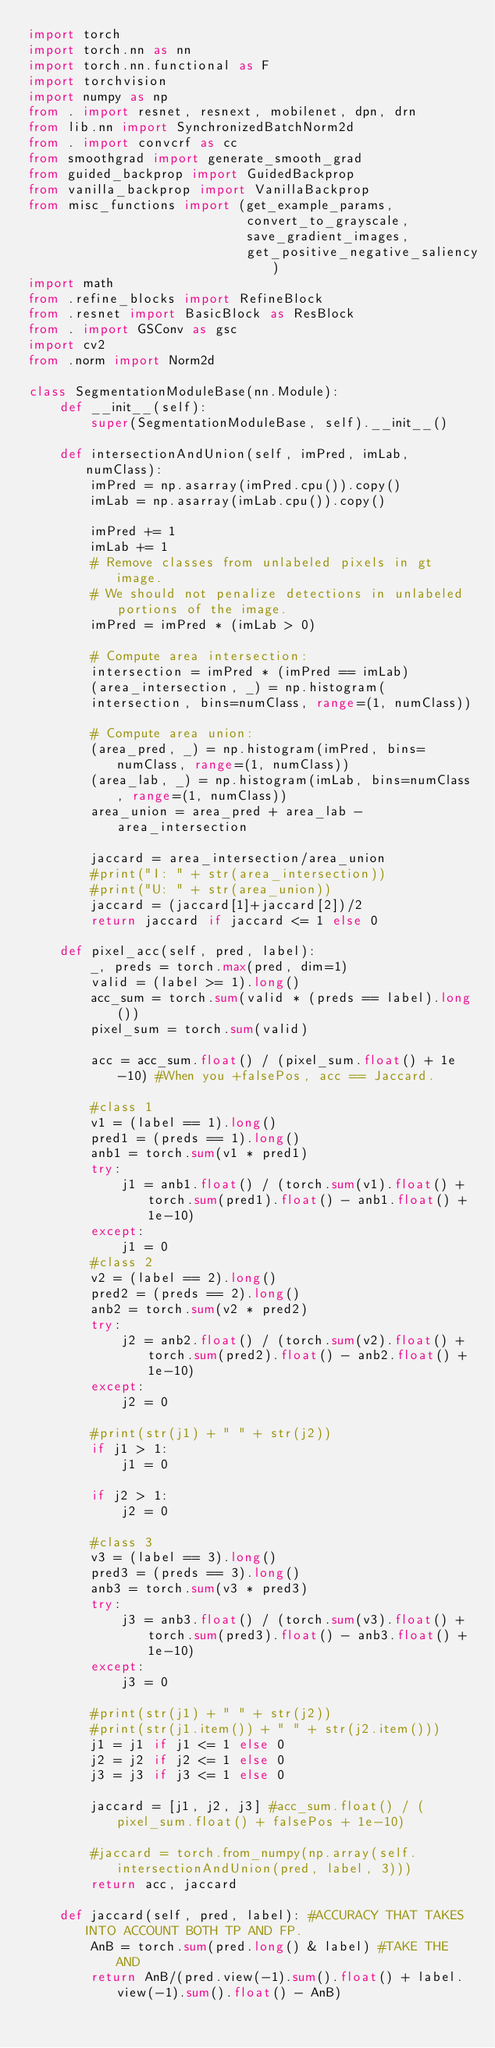<code> <loc_0><loc_0><loc_500><loc_500><_Python_>import torch
import torch.nn as nn
import torch.nn.functional as F
import torchvision
import numpy as np
from . import resnet, resnext, mobilenet, dpn, drn
from lib.nn import SynchronizedBatchNorm2d
from . import convcrf as cc
from smoothgrad import generate_smooth_grad
from guided_backprop import GuidedBackprop
from vanilla_backprop import VanillaBackprop
from misc_functions import (get_example_params,
                            convert_to_grayscale,
                            save_gradient_images,
                            get_positive_negative_saliency)
import math
from .refine_blocks import RefineBlock
from .resnet import BasicBlock as ResBlock
from . import GSConv as gsc
import cv2
from .norm import Norm2d

class SegmentationModuleBase(nn.Module):
    def __init__(self):
        super(SegmentationModuleBase, self).__init__()
    
    def intersectionAndUnion(self, imPred, imLab, numClass):
        imPred = np.asarray(imPred.cpu()).copy()
        imLab = np.asarray(imLab.cpu()).copy()

        imPred += 1
        imLab += 1
        # Remove classes from unlabeled pixels in gt image.
        # We should not penalize detections in unlabeled portions of the image.
        imPred = imPred * (imLab > 0)

        # Compute area intersection:
        intersection = imPred * (imPred == imLab)
        (area_intersection, _) = np.histogram(
        intersection, bins=numClass, range=(1, numClass))

        # Compute area union:
        (area_pred, _) = np.histogram(imPred, bins=numClass, range=(1, numClass))
        (area_lab, _) = np.histogram(imLab, bins=numClass, range=(1, numClass))
        area_union = area_pred + area_lab - area_intersection
        
        jaccard = area_intersection/area_union
        #print("I: " + str(area_intersection))
        #print("U: " + str(area_union))
        jaccard = (jaccard[1]+jaccard[2])/2
        return jaccard if jaccard <= 1 else 0

    def pixel_acc(self, pred, label):
        _, preds = torch.max(pred, dim=1)
        valid = (label >= 1).long()
        acc_sum = torch.sum(valid * (preds == label).long())
        pixel_sum = torch.sum(valid)

        acc = acc_sum.float() / (pixel_sum.float() + 1e-10) #When you +falsePos, acc == Jaccard.
        
        #class 1
        v1 = (label == 1).long()
        pred1 = (preds == 1).long()
        anb1 = torch.sum(v1 * pred1)
        try:
            j1 = anb1.float() / (torch.sum(v1).float() + torch.sum(pred1).float() - anb1.float() + 1e-10)
        except:
            j1 = 0
        #class 2 
        v2 = (label == 2).long()
        pred2 = (preds == 2).long()
        anb2 = torch.sum(v2 * pred2)
        try: 
            j2 = anb2.float() / (torch.sum(v2).float() + torch.sum(pred2).float() - anb2.float() + 1e-10)
        except:
            j2 = 0

        #print(str(j1) + " " + str(j2))
        if j1 > 1:
            j1 = 0

        if j2 > 1:
            j2 = 0
        
        #class 3
        v3 = (label == 3).long()
        pred3 = (preds == 3).long()
        anb3 = torch.sum(v3 * pred3)
        try:
            j3 = anb3.float() / (torch.sum(v3).float() + torch.sum(pred3).float() - anb3.float() + 1e-10)
        except:
            j3 = 0

        #print(str(j1) + " " + str(j2))
        #print(str(j1.item()) + " " + str(j2.item()))
        j1 = j1 if j1 <= 1 else 0
        j2 = j2 if j2 <= 1 else 0
        j3 = j3 if j3 <= 1 else 0
        
        jaccard = [j1, j2, j3] #acc_sum.float() / (pixel_sum.float() + falsePos + 1e-10)
        
        #jaccard = torch.from_numpy(np.array(self.intersectionAndUnion(pred, label, 3)))
        return acc, jaccard

    def jaccard(self, pred, label): #ACCURACY THAT TAKES INTO ACCOUNT BOTH TP AND FP.
        AnB = torch.sum(pred.long() & label) #TAKE THE AND
        return AnB/(pred.view(-1).sum().float() + label.view(-1).sum().float() - AnB)
    </code> 